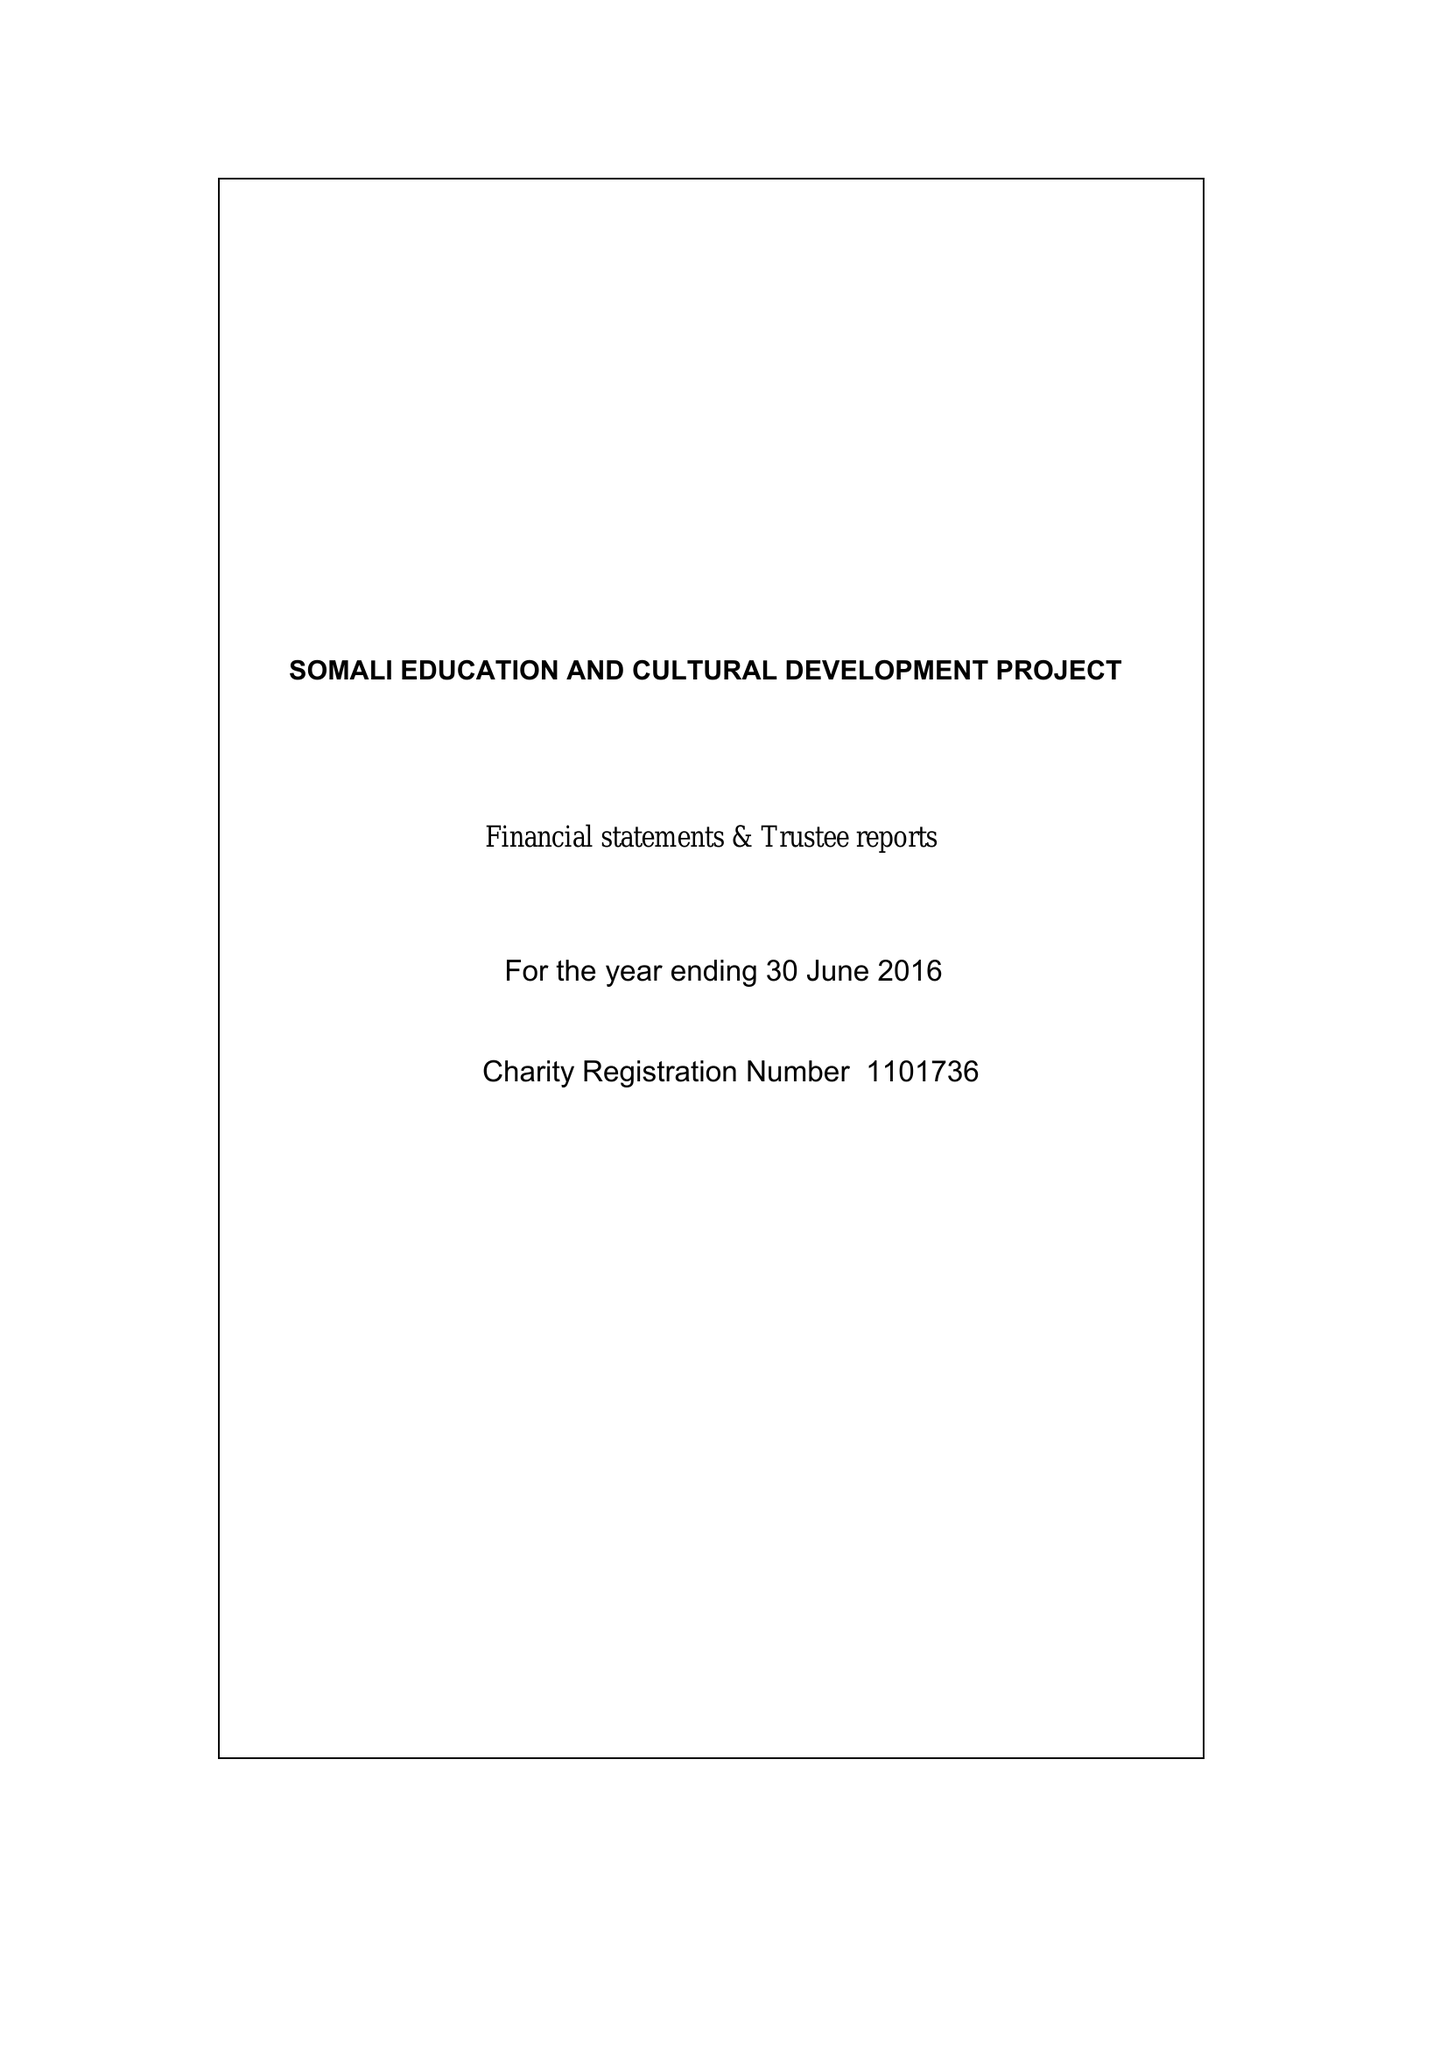What is the value for the spending_annually_in_british_pounds?
Answer the question using a single word or phrase. 30024.00 